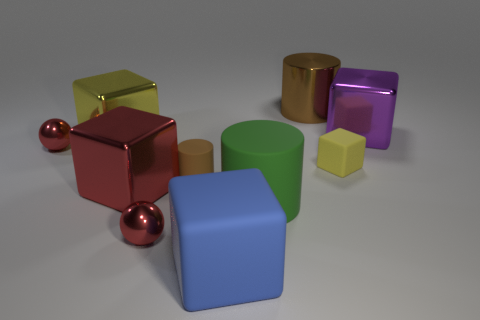Subtract all cyan cubes. Subtract all purple cylinders. How many cubes are left? 5 Subtract all cylinders. How many objects are left? 7 Add 8 small matte spheres. How many small matte spheres exist? 8 Subtract 0 gray cubes. How many objects are left? 10 Subtract all small purple metal objects. Subtract all big objects. How many objects are left? 4 Add 5 red shiny balls. How many red shiny balls are left? 7 